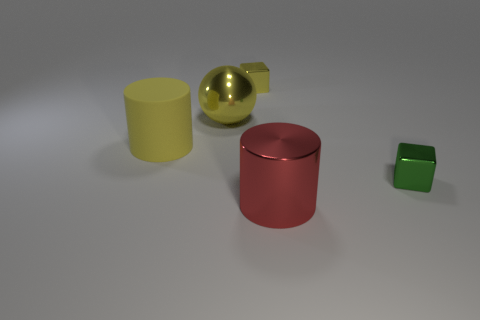What size is the matte cylinder?
Ensure brevity in your answer.  Large. There is a small block that is on the left side of the large red cylinder; does it have the same color as the big rubber cylinder?
Keep it short and to the point. Yes. Is the number of large things behind the large matte cylinder greater than the number of things in front of the shiny cylinder?
Make the answer very short. Yes. Are there more big metallic balls than brown cubes?
Your answer should be compact. Yes. What size is the shiny object that is in front of the big yellow rubber cylinder and on the left side of the tiny green block?
Your answer should be compact. Large. The red shiny object has what shape?
Keep it short and to the point. Cylinder. Is there anything else that has the same size as the yellow sphere?
Keep it short and to the point. Yes. Is the number of small cubes right of the green object greater than the number of gray spheres?
Make the answer very short. No. What is the shape of the large shiny thing behind the block in front of the big metallic object that is behind the yellow rubber cylinder?
Keep it short and to the point. Sphere. There is a yellow metal object behind the sphere; does it have the same size as the small green metallic cube?
Make the answer very short. Yes. 